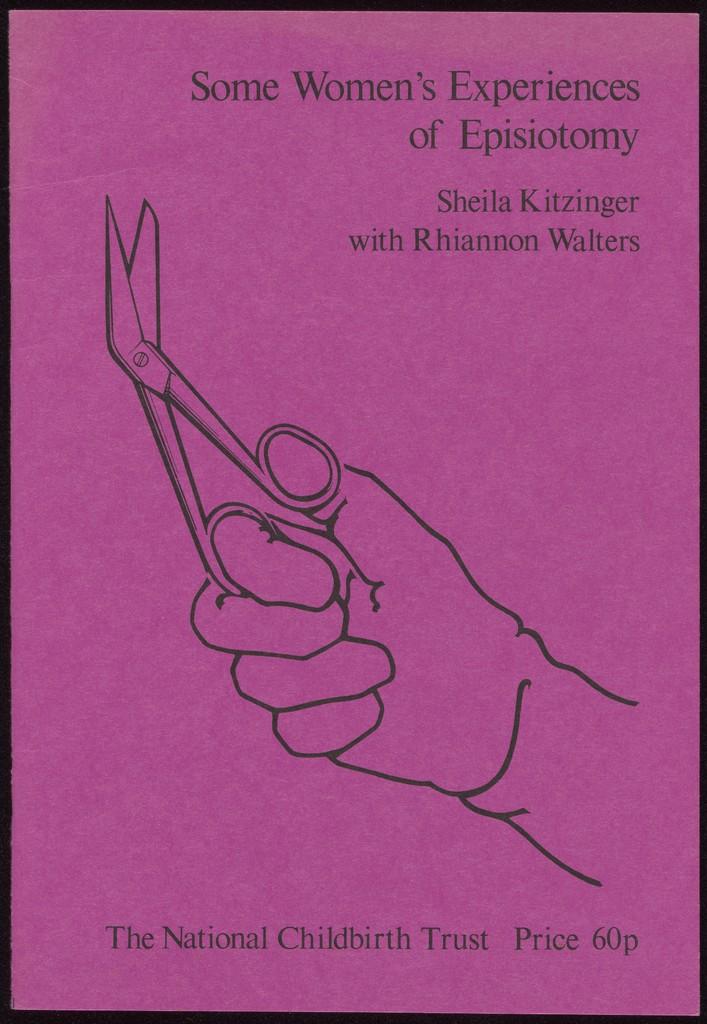Who is the main author of the book?
Make the answer very short. Sheila kitzinger. What is the name of the suthor?
Provide a short and direct response. Sheila kitzinger. 